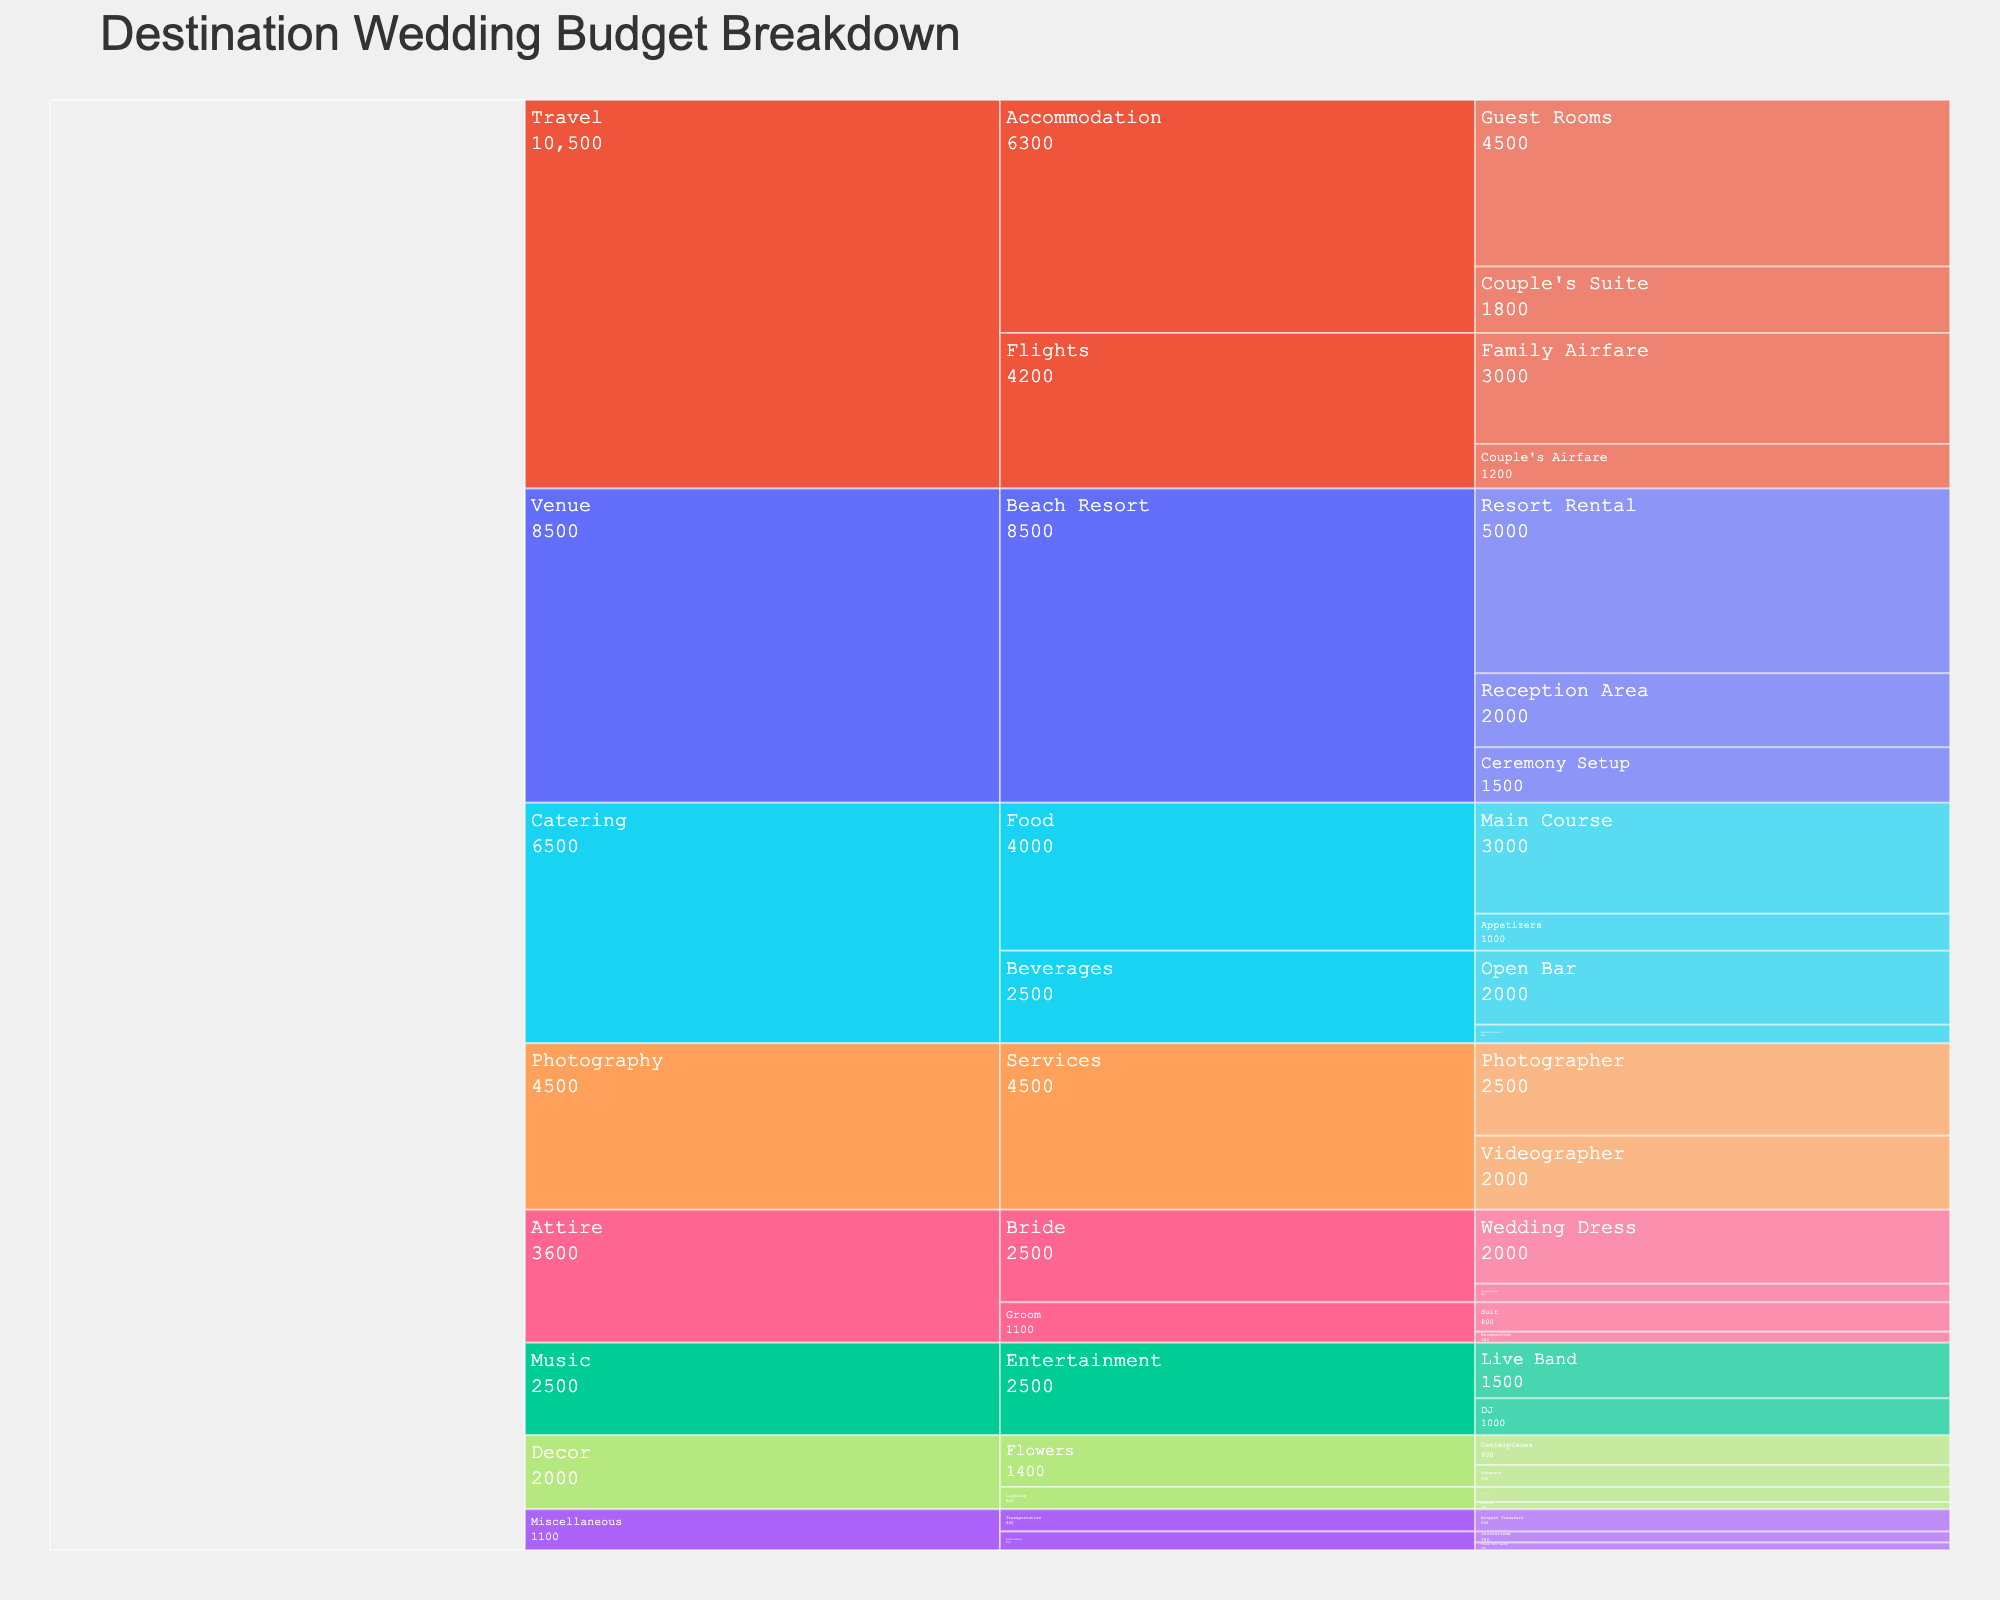Which category has the highest total cost? By analyzing the top level of the icicle chart, we can sum the cost of each category and find which one is the highest. The 'Travel' category spans Flights and Accommodation with significant sub-costs.
Answer: Travel How much does the 'Catering' category cost in total? The 'Catering' category contains 'Food' and 'Beverages'. To find the total cost, add up all the items under these subcategories: Main Course ($3000) + Appetizers ($1000) + Open Bar ($2000) + Non-Alcoholic ($500).
Answer: $6,500 In the 'Venue' category, which item under 'Beach Resort' costs the most? Under 'Venue' > 'Beach Resort', the items are 'Resort Rental' ($5000), 'Ceremony Setup' ($1500), and 'Reception Area' ($2000). The highest cost among these is 'Resort Rental'.
Answer: Resort Rental What is the cost difference between the 'DJ' and the 'Live Band' in the 'Music' category? In the 'Music' category, 'DJ' costs $1000 and 'Live Band' costs $1500. The cost difference is $1500 - $1000.
Answer: $500 Which subcategory has the lowest total cost under 'Miscellaneous'? 'Miscellaneous' contains 'Stationery' and 'Transportation'. 'Stationery' includes 'Invitations' ($300) and 'Thank You Cards' ($200) totalling $500. 'Transportation' includes 'Airport Transfers' totaling $600. The lowest total cost is in 'Stationery'.
Answer: Stationery What's the combined cost of 'Bride' and 'Groom' attire? 'Bride' attire includes 'Wedding Dress' ($2000) and 'Accessories' ($500), totaling $2500. 'Groom' attire includes 'Suit' ($800) and 'Accessories' ($300), totaling $1100. The combined cost is $2500 + $1100.
Answer: $3,600 How much does 'Photography' services cost in total? Under 'Photography', the services include 'Photographer' ($2500) and 'Videographer' ($2000). Adding these together gives the total cost.
Answer: $4,500 Which has a higher cost, 'Food' under 'Catering' or 'Family Airfare' under 'Travel'? 'Food' under 'Catering' includes 'Main Course' ($3000) and 'Appetizers' ($1000), which sum to $4000. 'Family Airfare' under 'Travel' is $3000. Comparing these, 'Food' has the higher cost.
Answer: Food What is the total budget for the wedding? To find the total budget, sum all individual costs listed in the chart. This involves summing across all categories and subcategories.
Answer: $35,500 What's the cost difference between the highest and lowest costing items under 'Decor'? Under 'Decor', the items and costs are: 'Bouquets' ($600), 'Centerpieces' ($800), 'String Lights' ($400), and 'Candles' ($200). The highest cost is 'Centerpieces' at $800, and the lowest is 'Candles' at $200. The difference is $800 - $200.
Answer: $600 